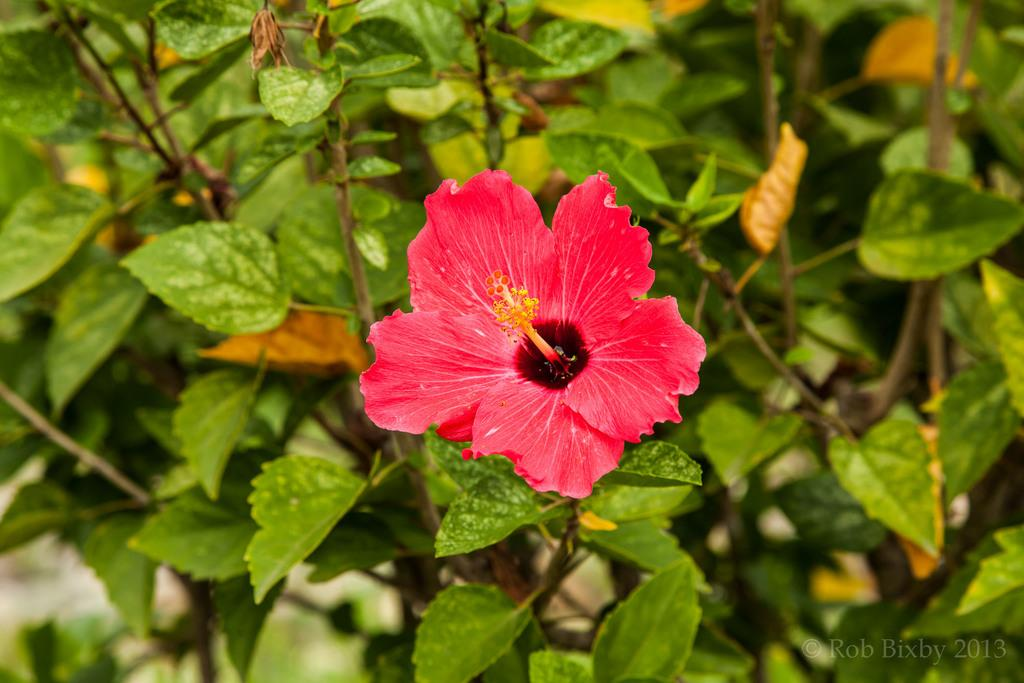What is present in the picture? There is a plant in the picture. Can you describe the flower on the plant? There is a red color flower in the center of the picture. How many eggs are present in the flock of birds in the picture? There are no birds or eggs present in the picture; it only features a plant with a red flower. 